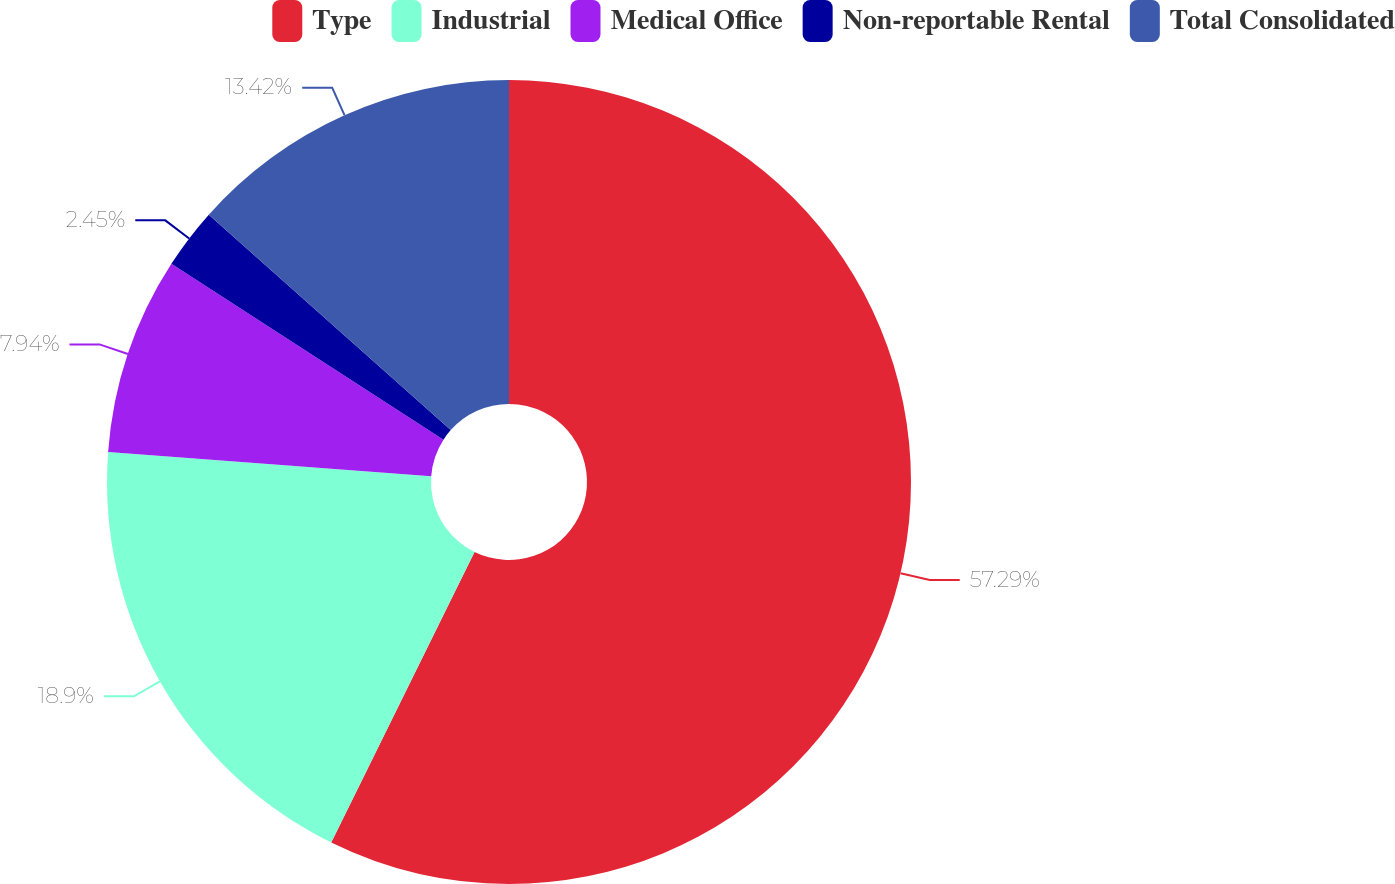Convert chart to OTSL. <chart><loc_0><loc_0><loc_500><loc_500><pie_chart><fcel>Type<fcel>Industrial<fcel>Medical Office<fcel>Non-reportable Rental<fcel>Total Consolidated<nl><fcel>57.29%<fcel>18.9%<fcel>7.94%<fcel>2.45%<fcel>13.42%<nl></chart> 